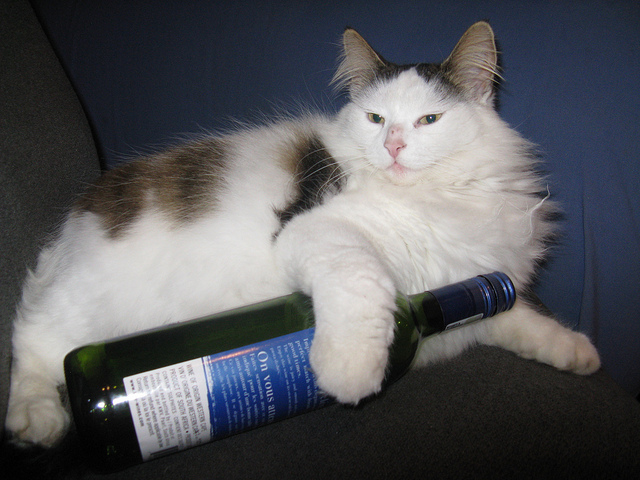Identify the text displayed in this image. vous 